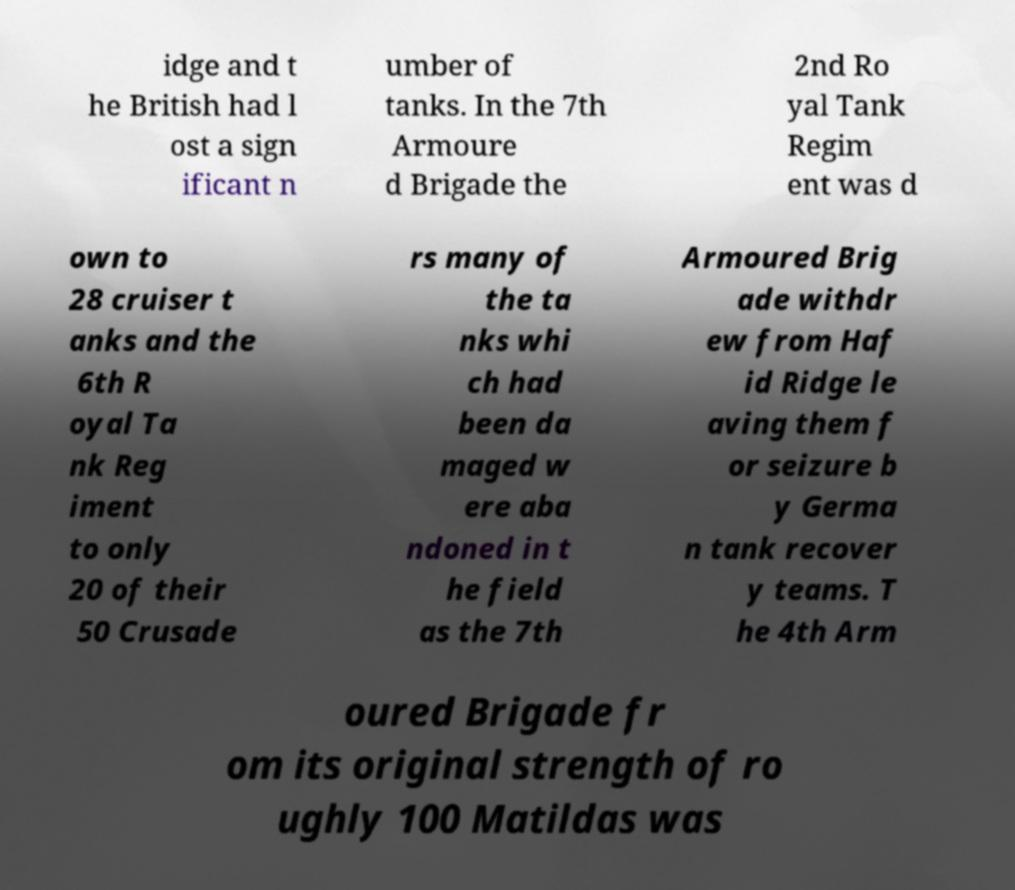Can you read and provide the text displayed in the image?This photo seems to have some interesting text. Can you extract and type it out for me? idge and t he British had l ost a sign ificant n umber of tanks. In the 7th Armoure d Brigade the 2nd Ro yal Tank Regim ent was d own to 28 cruiser t anks and the 6th R oyal Ta nk Reg iment to only 20 of their 50 Crusade rs many of the ta nks whi ch had been da maged w ere aba ndoned in t he field as the 7th Armoured Brig ade withdr ew from Haf id Ridge le aving them f or seizure b y Germa n tank recover y teams. T he 4th Arm oured Brigade fr om its original strength of ro ughly 100 Matildas was 